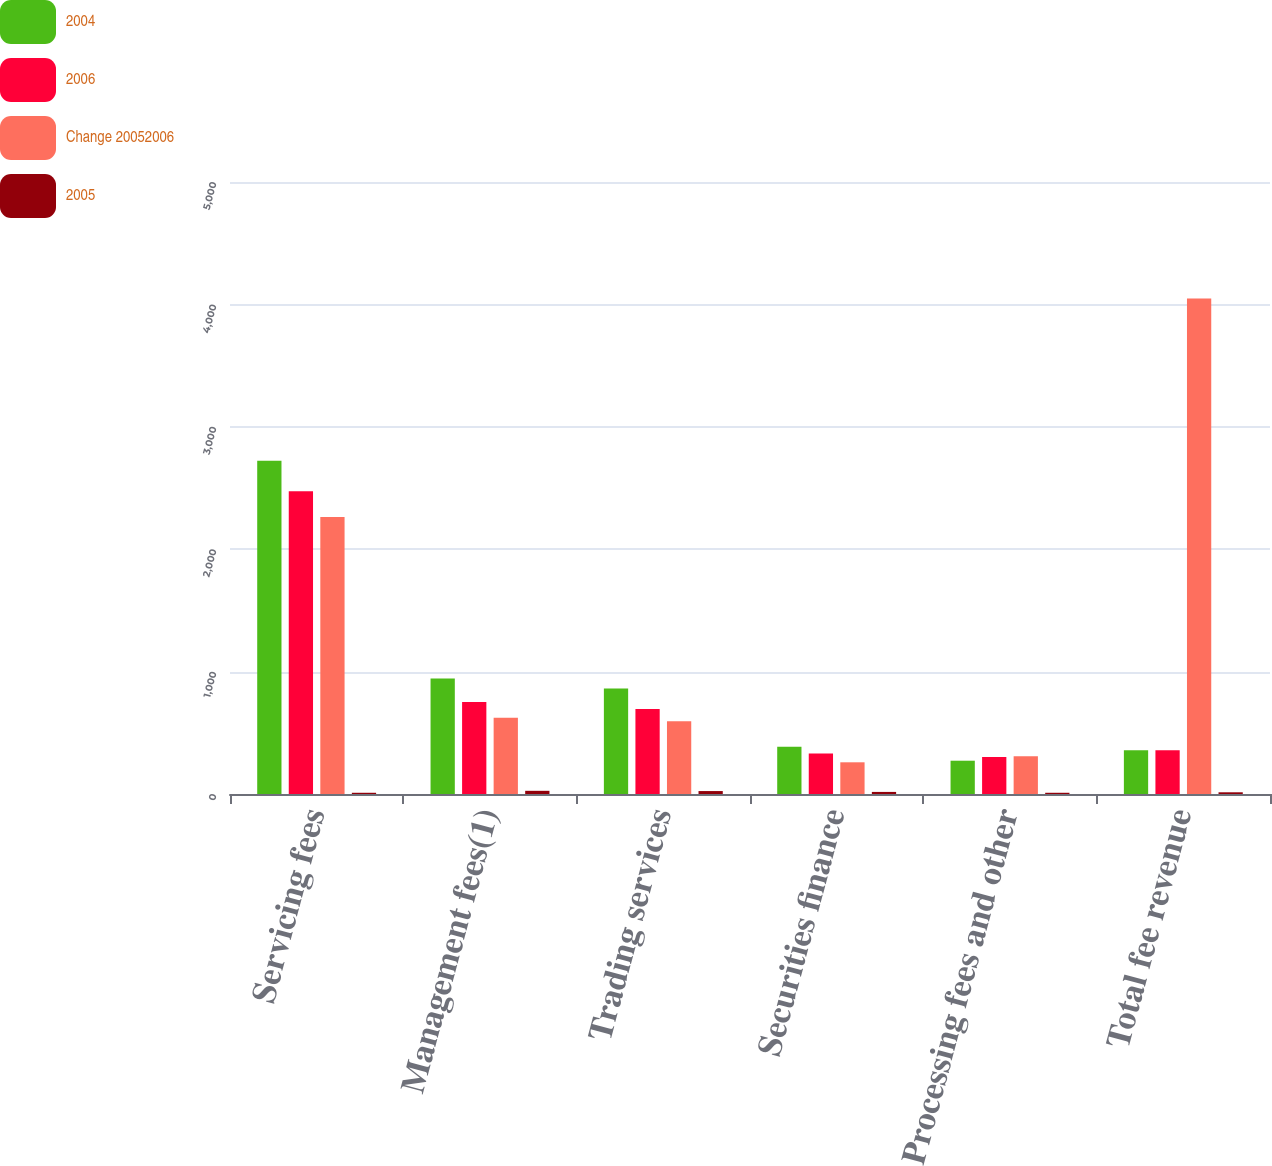Convert chart. <chart><loc_0><loc_0><loc_500><loc_500><stacked_bar_chart><ecel><fcel>Servicing fees<fcel>Management fees(1)<fcel>Trading services<fcel>Securities finance<fcel>Processing fees and other<fcel>Total fee revenue<nl><fcel>2004<fcel>2723<fcel>943<fcel>862<fcel>386<fcel>272<fcel>358<nl><fcel>2006<fcel>2474<fcel>751<fcel>694<fcel>330<fcel>302<fcel>358<nl><fcel>Change 20052006<fcel>2263<fcel>623<fcel>595<fcel>259<fcel>308<fcel>4048<nl><fcel>2005<fcel>10<fcel>26<fcel>24<fcel>17<fcel>10<fcel>14<nl></chart> 